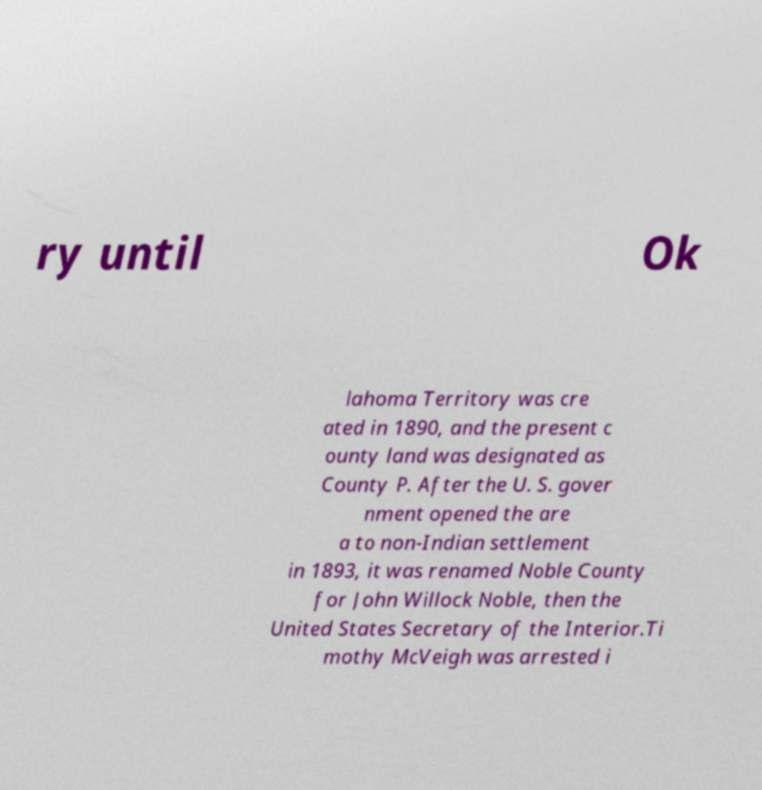Can you accurately transcribe the text from the provided image for me? ry until Ok lahoma Territory was cre ated in 1890, and the present c ounty land was designated as County P. After the U. S. gover nment opened the are a to non-Indian settlement in 1893, it was renamed Noble County for John Willock Noble, then the United States Secretary of the Interior.Ti mothy McVeigh was arrested i 